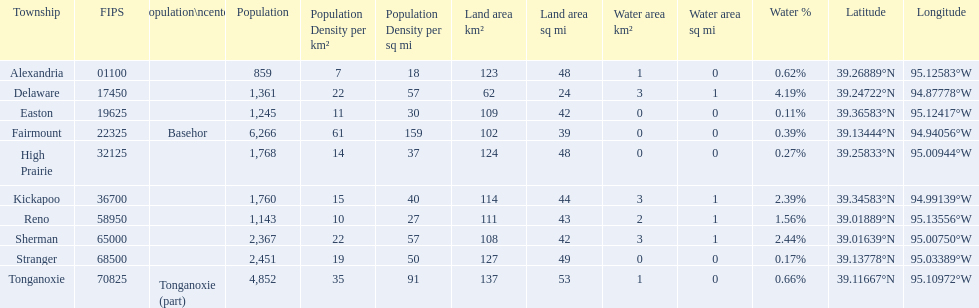What township has the most land area? Tonganoxie. 